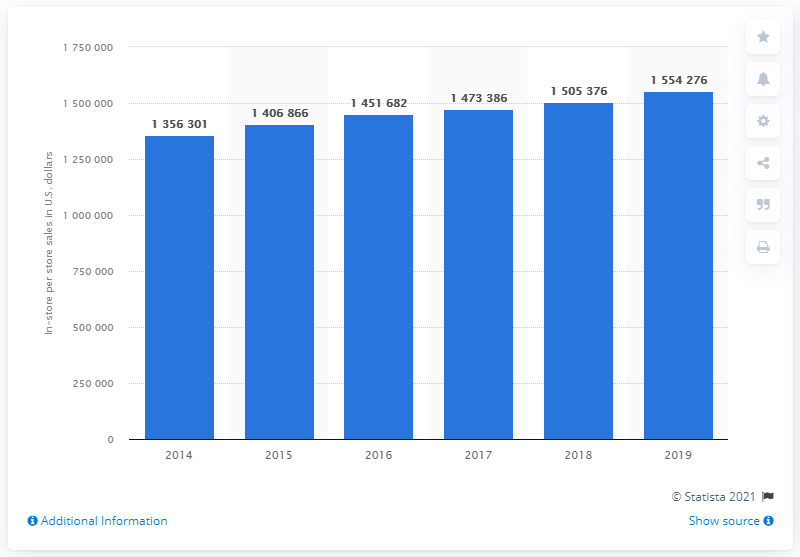Specify some key components in this picture. In 2019, the estimated number of dollars in store sales per U.S. convenience store was approximately 155,427,600. In 2019, the in-store sales per convenience store in the United States were approximately 155,427.6. 